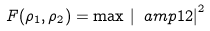Convert formula to latex. <formula><loc_0><loc_0><loc_500><loc_500>F ( \rho _ { 1 } , \rho _ { 2 } ) = \max \, \left | \ a m p { 1 } { 2 } \right | ^ { 2 }</formula> 